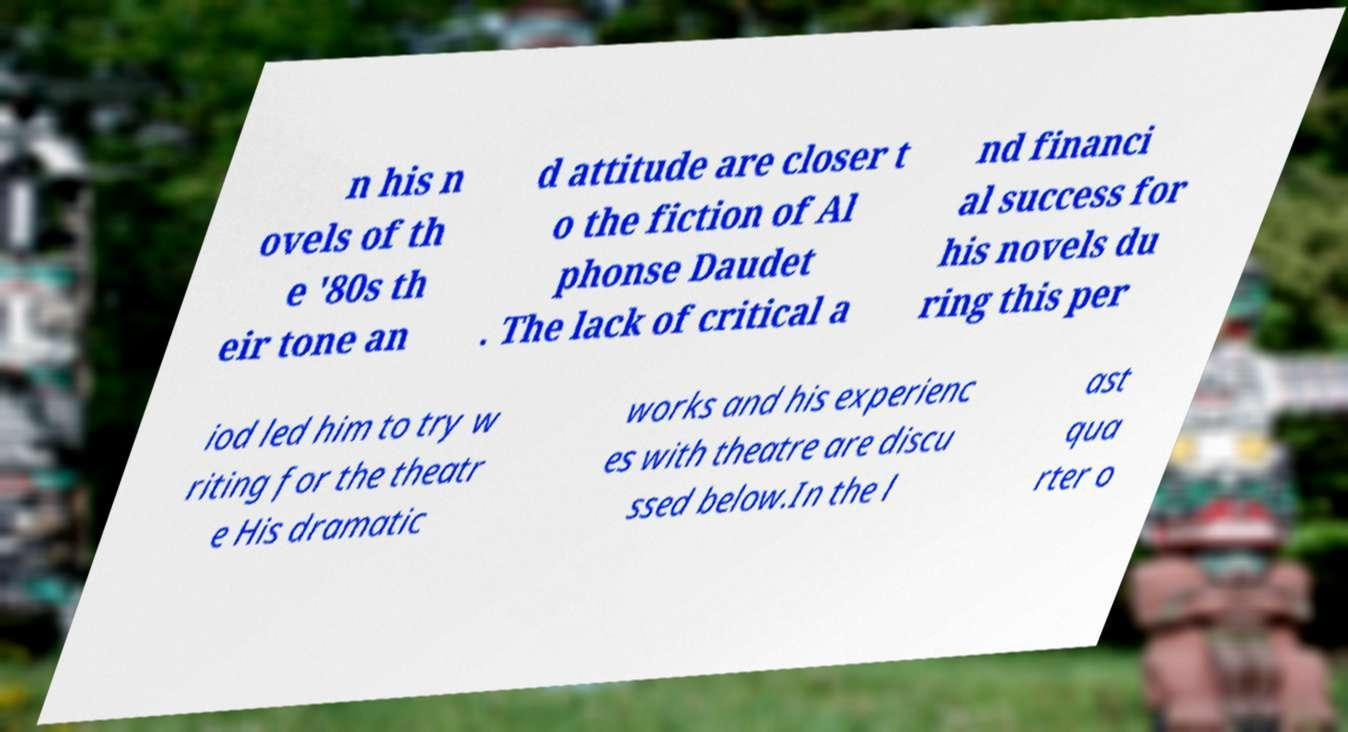I need the written content from this picture converted into text. Can you do that? n his n ovels of th e '80s th eir tone an d attitude are closer t o the fiction of Al phonse Daudet . The lack of critical a nd financi al success for his novels du ring this per iod led him to try w riting for the theatr e His dramatic works and his experienc es with theatre are discu ssed below.In the l ast qua rter o 